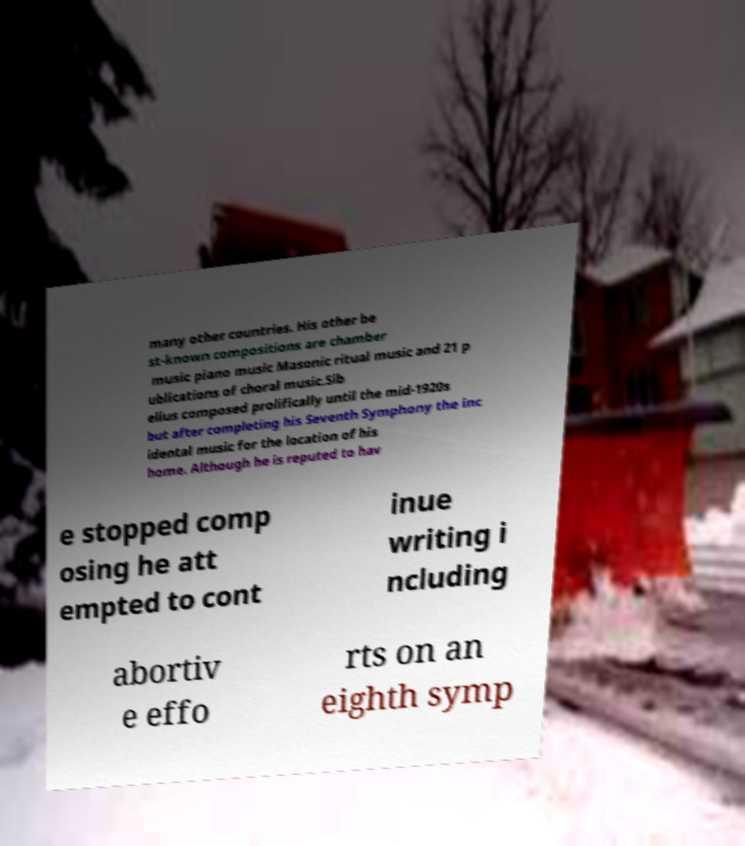I need the written content from this picture converted into text. Can you do that? many other countries. His other be st-known compositions are chamber music piano music Masonic ritual music and 21 p ublications of choral music.Sib elius composed prolifically until the mid-1920s but after completing his Seventh Symphony the inc idental music for the location of his home. Although he is reputed to hav e stopped comp osing he att empted to cont inue writing i ncluding abortiv e effo rts on an eighth symp 